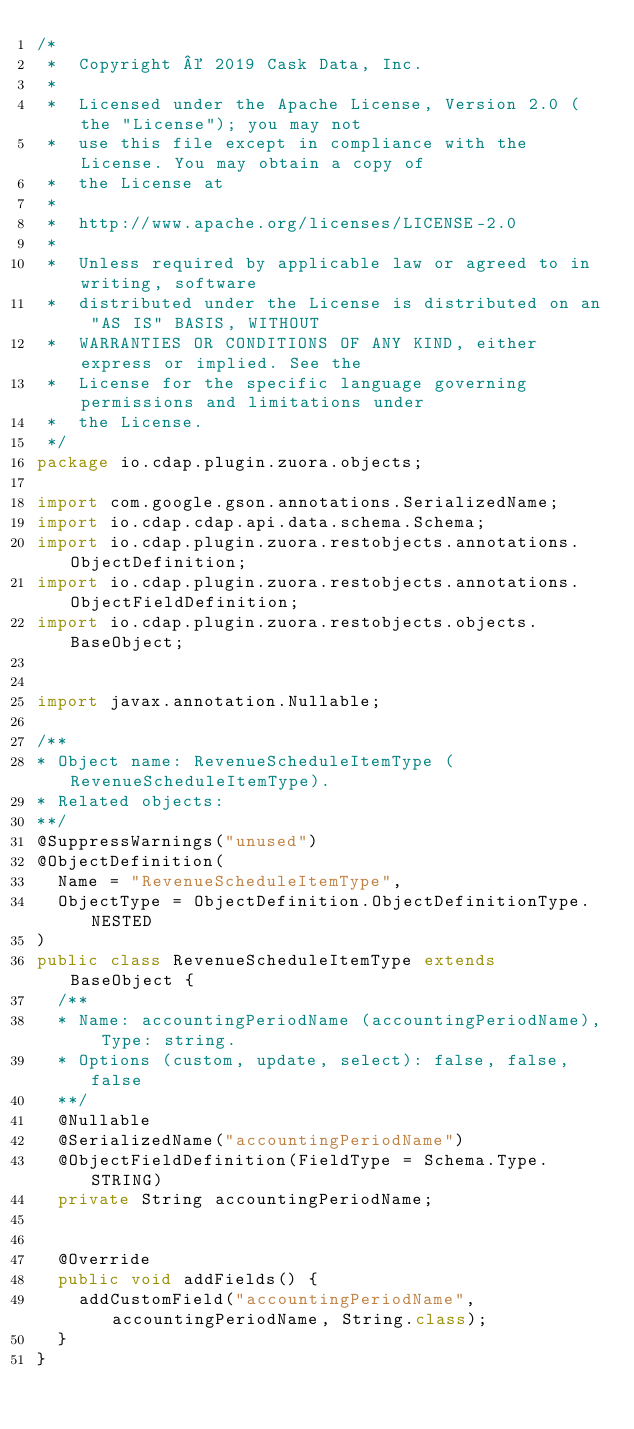<code> <loc_0><loc_0><loc_500><loc_500><_Java_>/*
 *  Copyright © 2019 Cask Data, Inc.
 *
 *  Licensed under the Apache License, Version 2.0 (the "License"); you may not
 *  use this file except in compliance with the License. You may obtain a copy of
 *  the License at
 *
 *  http://www.apache.org/licenses/LICENSE-2.0
 *
 *  Unless required by applicable law or agreed to in writing, software
 *  distributed under the License is distributed on an "AS IS" BASIS, WITHOUT
 *  WARRANTIES OR CONDITIONS OF ANY KIND, either express or implied. See the
 *  License for the specific language governing permissions and limitations under
 *  the License.
 */
package io.cdap.plugin.zuora.objects;

import com.google.gson.annotations.SerializedName;
import io.cdap.cdap.api.data.schema.Schema;
import io.cdap.plugin.zuora.restobjects.annotations.ObjectDefinition;
import io.cdap.plugin.zuora.restobjects.annotations.ObjectFieldDefinition;
import io.cdap.plugin.zuora.restobjects.objects.BaseObject;


import javax.annotation.Nullable;

/**
* Object name: RevenueScheduleItemType (RevenueScheduleItemType).
* Related objects:
**/
@SuppressWarnings("unused")
@ObjectDefinition(
  Name = "RevenueScheduleItemType",
  ObjectType = ObjectDefinition.ObjectDefinitionType.NESTED
)
public class RevenueScheduleItemType extends BaseObject {
  /**
  * Name: accountingPeriodName (accountingPeriodName), Type: string.
  * Options (custom, update, select): false, false, false
  **/
  @Nullable
  @SerializedName("accountingPeriodName")
  @ObjectFieldDefinition(FieldType = Schema.Type.STRING)
  private String accountingPeriodName;


  @Override
  public void addFields() {
    addCustomField("accountingPeriodName", accountingPeriodName, String.class);
  }
}
</code> 